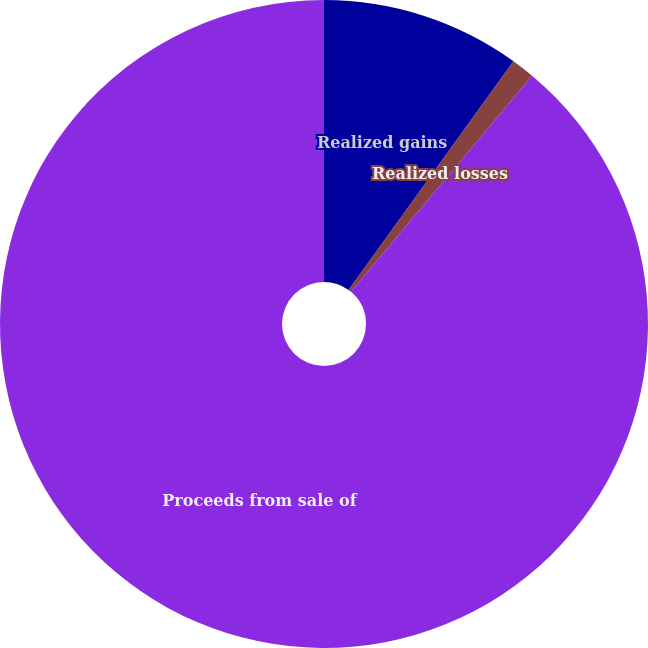Convert chart. <chart><loc_0><loc_0><loc_500><loc_500><pie_chart><fcel>Realized gains<fcel>Realized losses<fcel>Proceeds from sale of<nl><fcel>9.94%<fcel>1.16%<fcel>88.9%<nl></chart> 